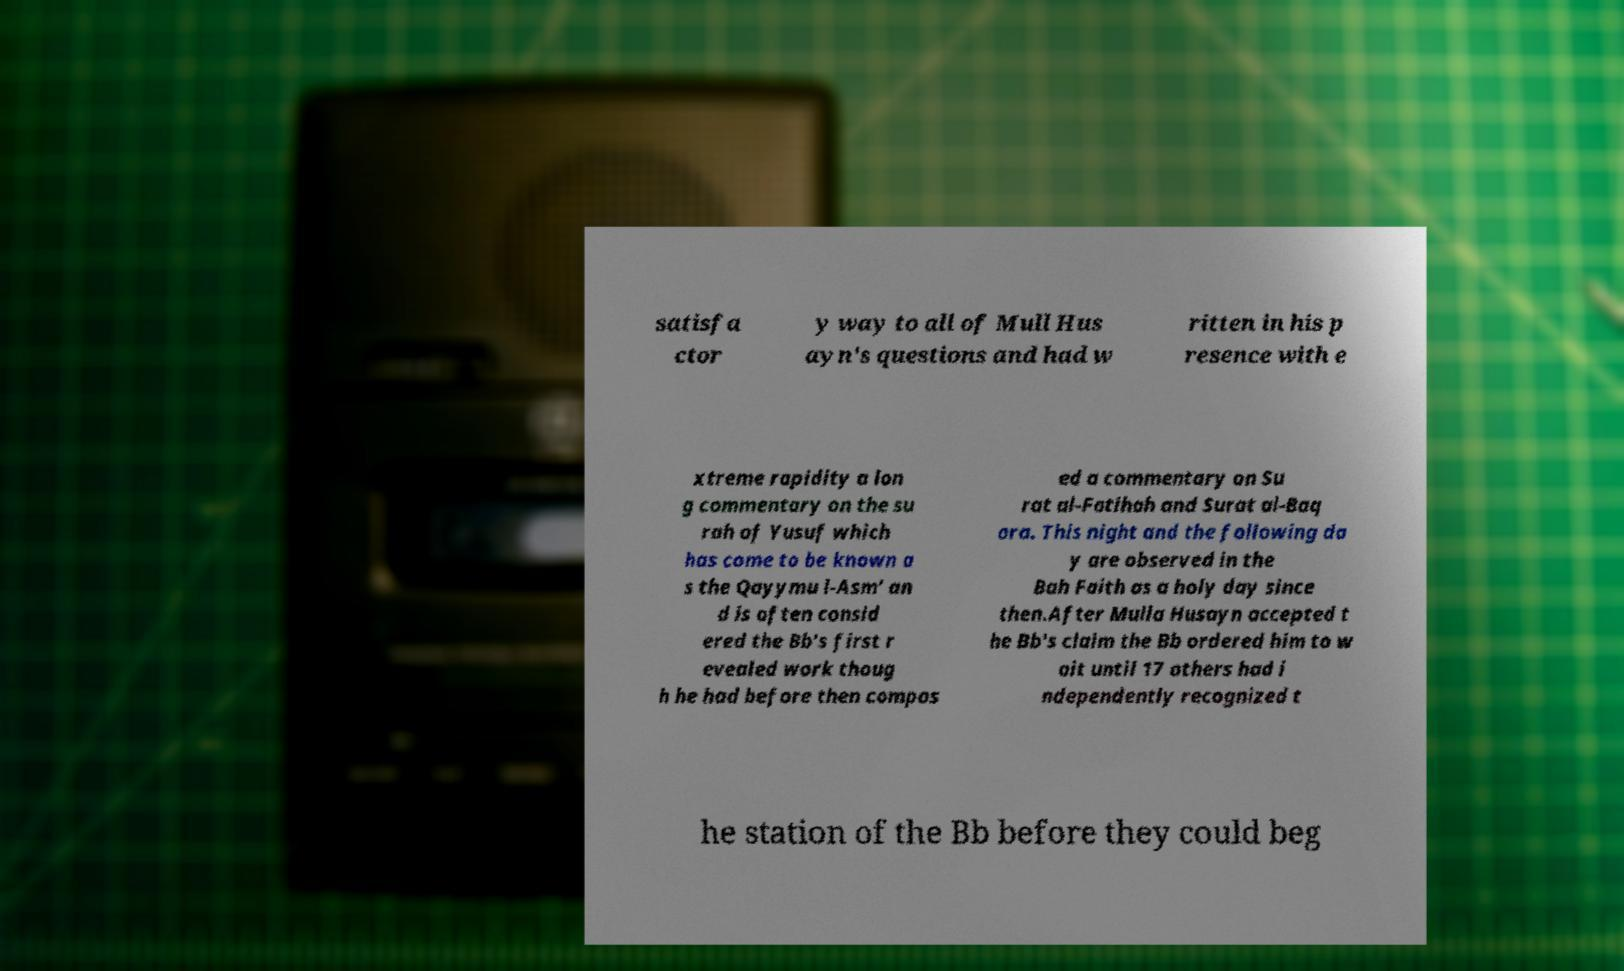Can you accurately transcribe the text from the provided image for me? satisfa ctor y way to all of Mull Hus ayn's questions and had w ritten in his p resence with e xtreme rapidity a lon g commentary on the su rah of Yusuf which has come to be known a s the Qayymu l-Asm' an d is often consid ered the Bb's first r evealed work thoug h he had before then compos ed a commentary on Su rat al-Fatihah and Surat al-Baq ara. This night and the following da y are observed in the Bah Faith as a holy day since then.After Mulla Husayn accepted t he Bb's claim the Bb ordered him to w ait until 17 others had i ndependently recognized t he station of the Bb before they could beg 